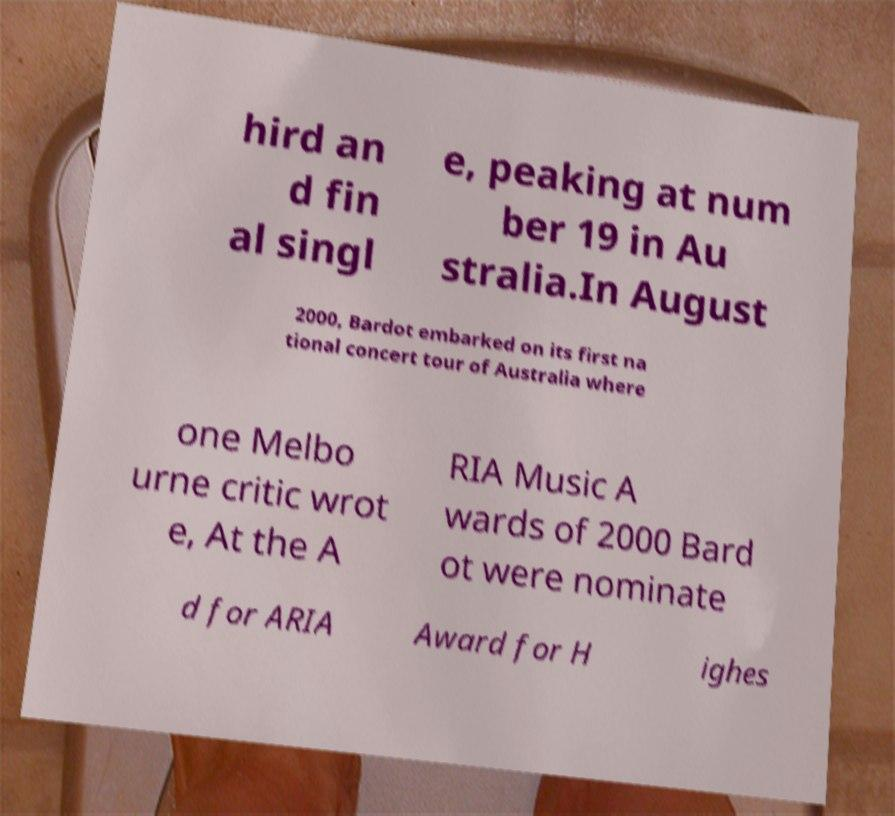For documentation purposes, I need the text within this image transcribed. Could you provide that? hird an d fin al singl e, peaking at num ber 19 in Au stralia.In August 2000, Bardot embarked on its first na tional concert tour of Australia where one Melbo urne critic wrot e, At the A RIA Music A wards of 2000 Bard ot were nominate d for ARIA Award for H ighes 